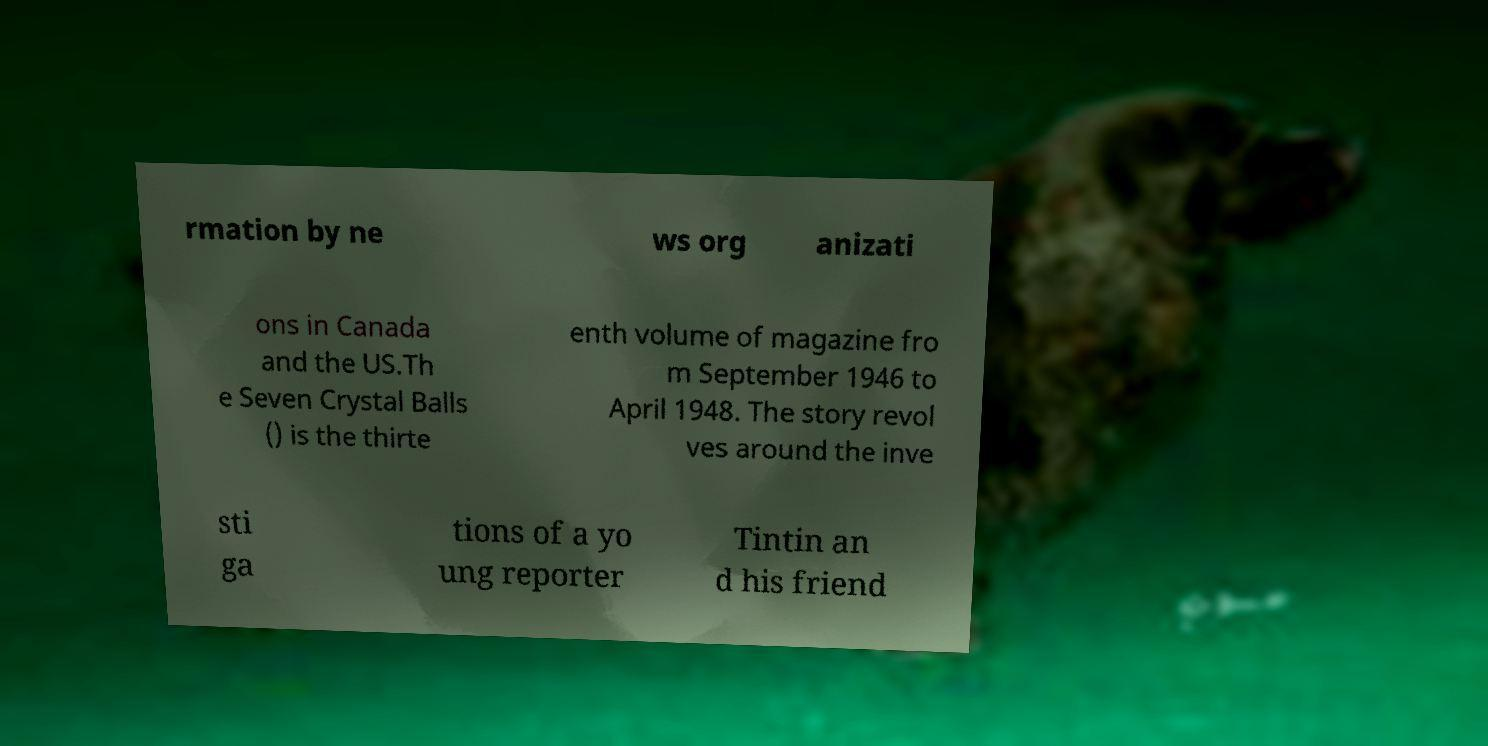For documentation purposes, I need the text within this image transcribed. Could you provide that? rmation by ne ws org anizati ons in Canada and the US.Th e Seven Crystal Balls () is the thirte enth volume of magazine fro m September 1946 to April 1948. The story revol ves around the inve sti ga tions of a yo ung reporter Tintin an d his friend 